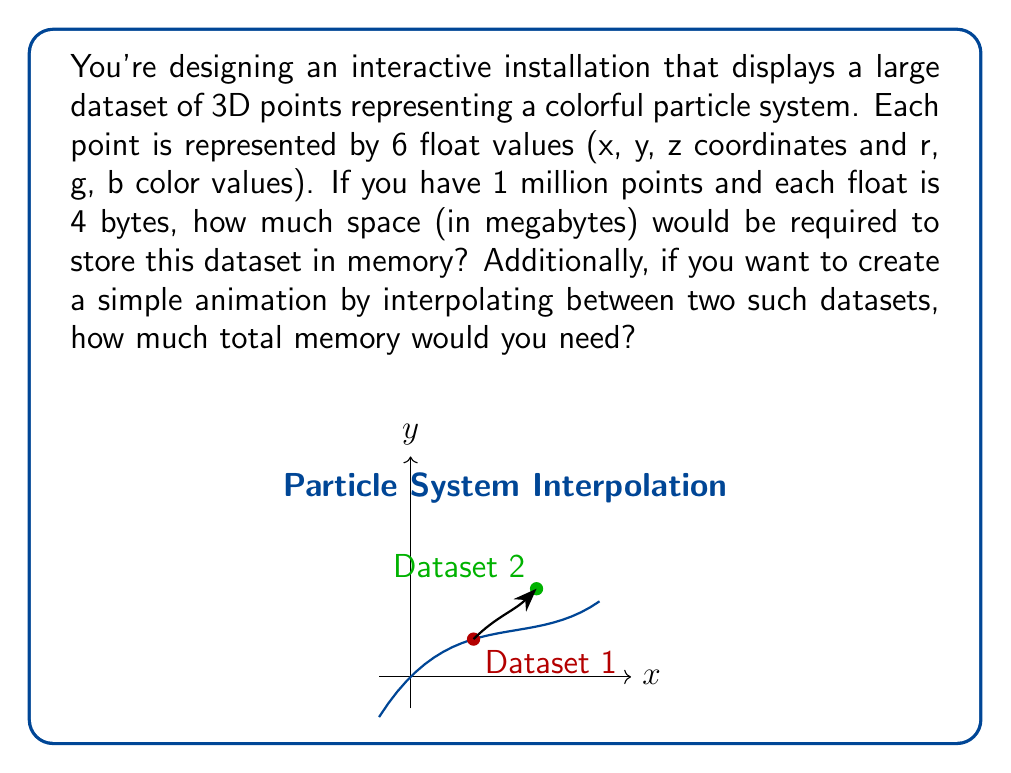Solve this math problem. Let's break this down step-by-step:

1) First, let's calculate the space required for one point:
   - Each point has 6 float values
   - Each float is 4 bytes
   - So, each point requires: $6 \times 4 = 24$ bytes

2) Now, let's calculate for 1 million points:
   - Total bytes = $24 \times 1,000,000 = 24,000,000$ bytes

3) To convert bytes to megabytes, we divide by $1,024^2$ (since 1 MB = 1,024 KB = 1,024 * 1,024 bytes):
   
   $$\frac{24,000,000}{1,024^2} \approx 22.89 \text{ MB}$$

4) For the animation, we need to store two complete datasets:
   - Memory required = $22.89 \times 2 \approx 45.78 \text{ MB}$

Therefore, to store one dataset, you'd need approximately 22.89 MB of memory. To create a simple animation by interpolating between two datasets, you'd need approximately 45.78 MB of memory.
Answer: 22.89 MB for one dataset; 45.78 MB for animation between two datasets 